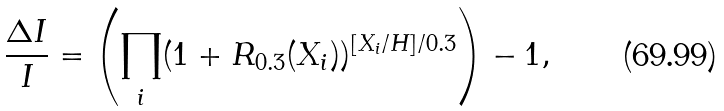<formula> <loc_0><loc_0><loc_500><loc_500>\frac { \Delta I } { I } = \left ( \prod _ { i } ( 1 + R _ { 0 . 3 } ( X _ { i } ) ) ^ { [ X _ { i } / H ] / 0 . 3 } \right ) - 1 ,</formula> 